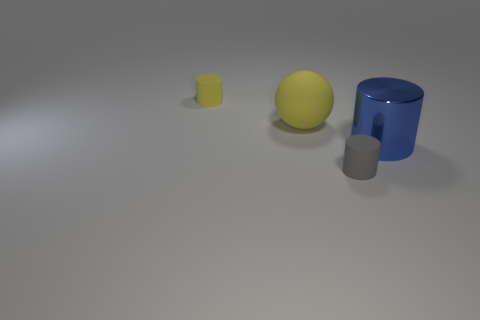There is a gray thing in front of the big rubber object; how big is it?
Offer a very short reply. Small. Are there any small cubes that have the same color as the big matte sphere?
Ensure brevity in your answer.  No. There is a tiny object that is behind the big matte ball; is there a yellow object that is on the left side of it?
Offer a terse response. No. Is the size of the matte ball the same as the yellow rubber thing that is behind the large yellow ball?
Your answer should be very brief. No. Is there a gray cylinder that is to the right of the tiny rubber thing that is to the right of the tiny rubber cylinder that is behind the tiny gray object?
Offer a terse response. No. There is a tiny cylinder to the left of the small gray matte object; what is it made of?
Give a very brief answer. Rubber. Is the size of the yellow cylinder the same as the shiny object?
Provide a succinct answer. No. There is a cylinder that is in front of the yellow cylinder and to the left of the blue metallic cylinder; what color is it?
Keep it short and to the point. Gray. The big object that is the same material as the tiny gray cylinder is what shape?
Ensure brevity in your answer.  Sphere. What number of things are both in front of the large yellow matte thing and behind the gray cylinder?
Give a very brief answer. 1. 